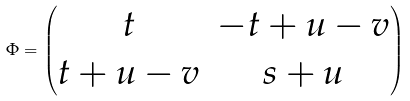<formula> <loc_0><loc_0><loc_500><loc_500>\Phi = \begin{pmatrix} t & - t + u - v \\ t + u - v & s + u \end{pmatrix}</formula> 